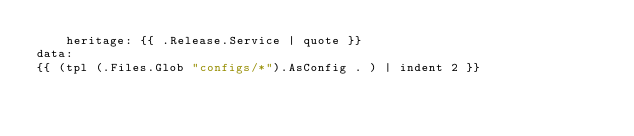Convert code to text. <code><loc_0><loc_0><loc_500><loc_500><_YAML_>    heritage: {{ .Release.Service | quote }}
data:
{{ (tpl (.Files.Glob "configs/*").AsConfig . ) | indent 2 }}
</code> 